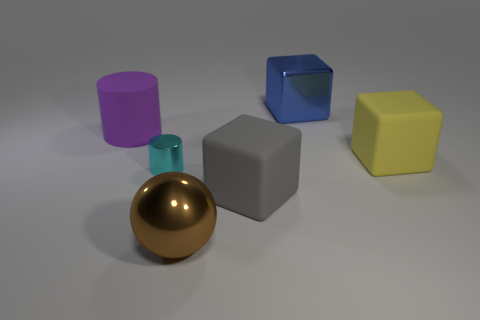If these objects were used in a game, which could be the most valuable and why? If these objects were part of a game, the golden sphere might be considered the most valuable due to its unique reflective surface and color, often associated with wealth and rarity in games. It could be used as the 'golden snitch' in gameplay, granting the player extra points or a special advantage once collected. 